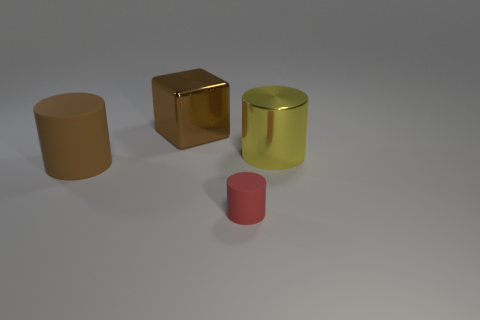Add 2 large blue matte spheres. How many objects exist? 6 Subtract all cylinders. How many objects are left? 1 Add 3 big yellow metallic cylinders. How many big yellow metallic cylinders exist? 4 Subtract 0 yellow spheres. How many objects are left? 4 Subtract all large yellow metal things. Subtract all brown rubber objects. How many objects are left? 2 Add 4 cylinders. How many cylinders are left? 7 